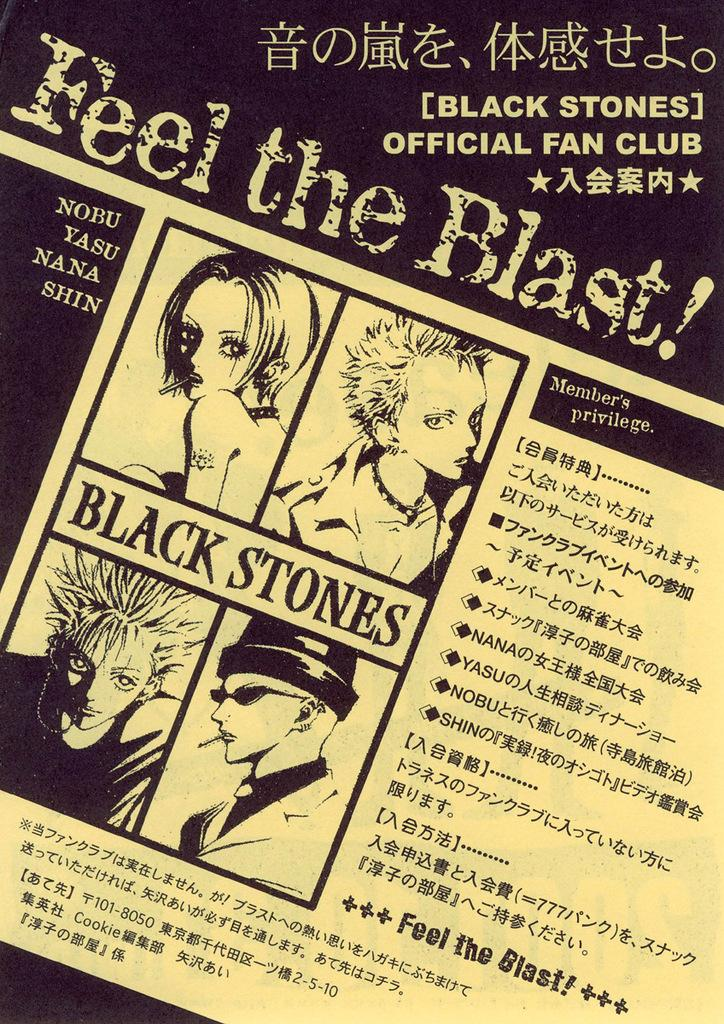What type of image is being described? The image is a poster. What is depicted in the poster? There are cartoons in the poster. Are there any words or letters in the poster? Yes, there is text in the poster. What type of laborer is shown working in the poster? There is no laborer present in the poster; it contains cartoons and text. Can you see a bear in the poster? There is no bear depicted in the poster; it features cartoons and text. 